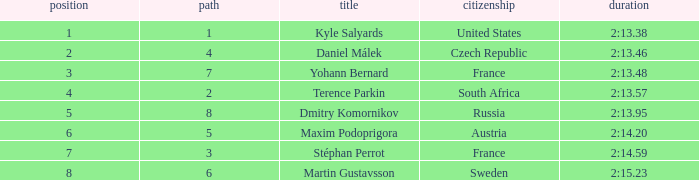What was Stéphan Perrot rank average? 7.0. 